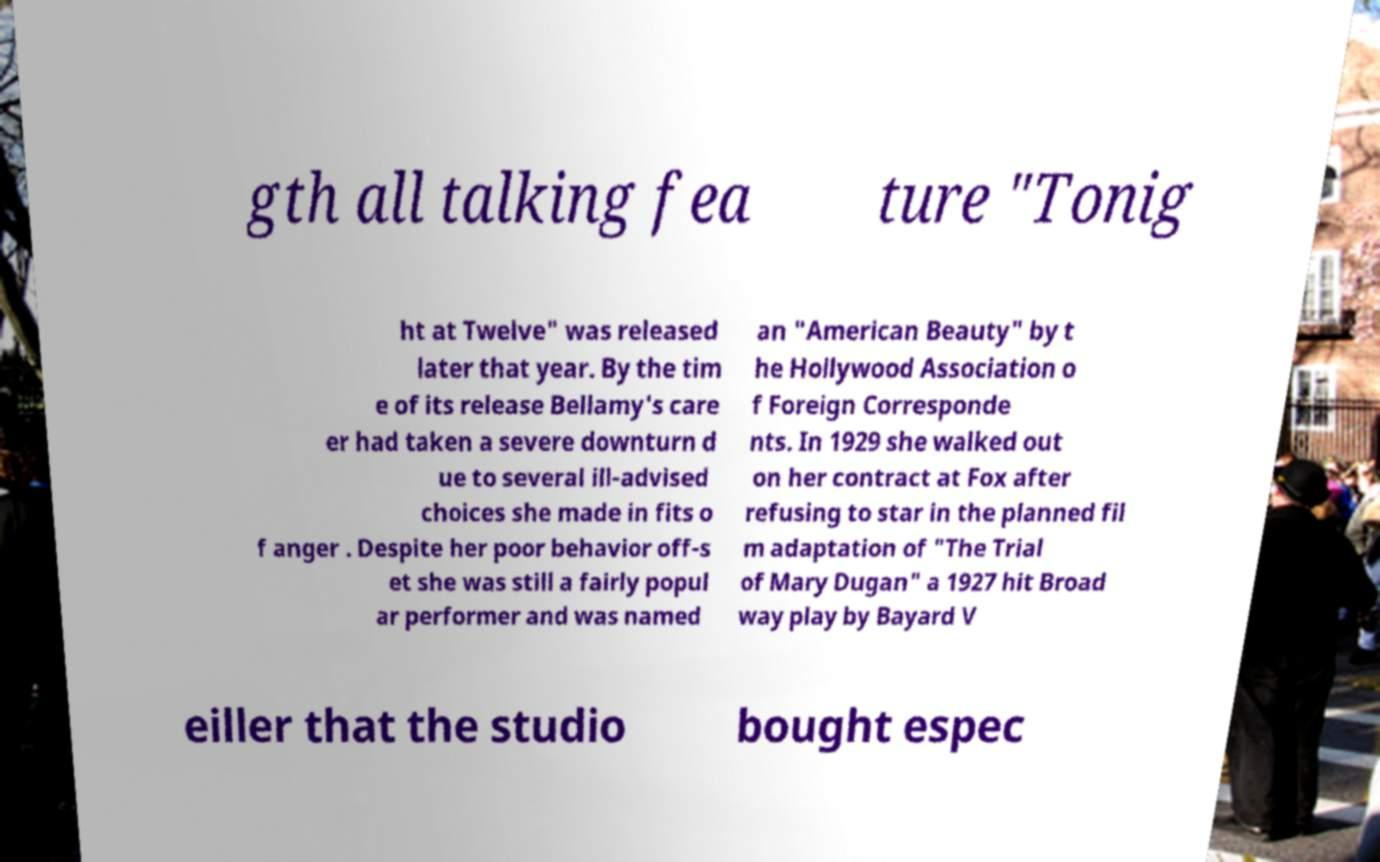I need the written content from this picture converted into text. Can you do that? gth all talking fea ture "Tonig ht at Twelve" was released later that year. By the tim e of its release Bellamy's care er had taken a severe downturn d ue to several ill-advised choices she made in fits o f anger . Despite her poor behavior off-s et she was still a fairly popul ar performer and was named an "American Beauty" by t he Hollywood Association o f Foreign Corresponde nts. In 1929 she walked out on her contract at Fox after refusing to star in the planned fil m adaptation of "The Trial of Mary Dugan" a 1927 hit Broad way play by Bayard V eiller that the studio bought espec 